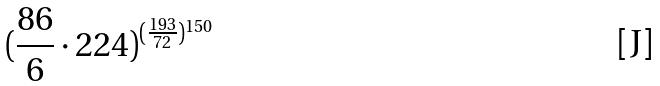Convert formula to latex. <formula><loc_0><loc_0><loc_500><loc_500>( \frac { 8 6 } { 6 } \cdot 2 2 4 ) ^ { ( \frac { 1 9 3 } { 7 2 } ) ^ { 1 5 0 } }</formula> 